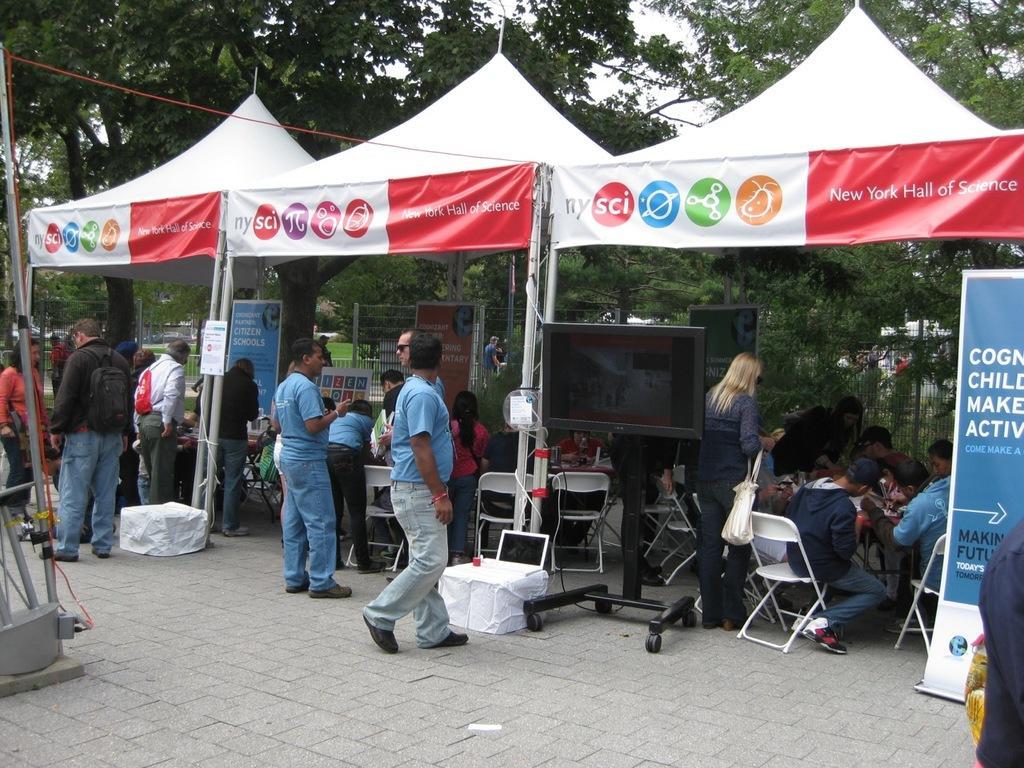How would you summarize this image in a sentence or two? In this image I can see few people standing. There are canopies and there are chairs,banners and a screen. There are trees at the back. There is sky at the top. 